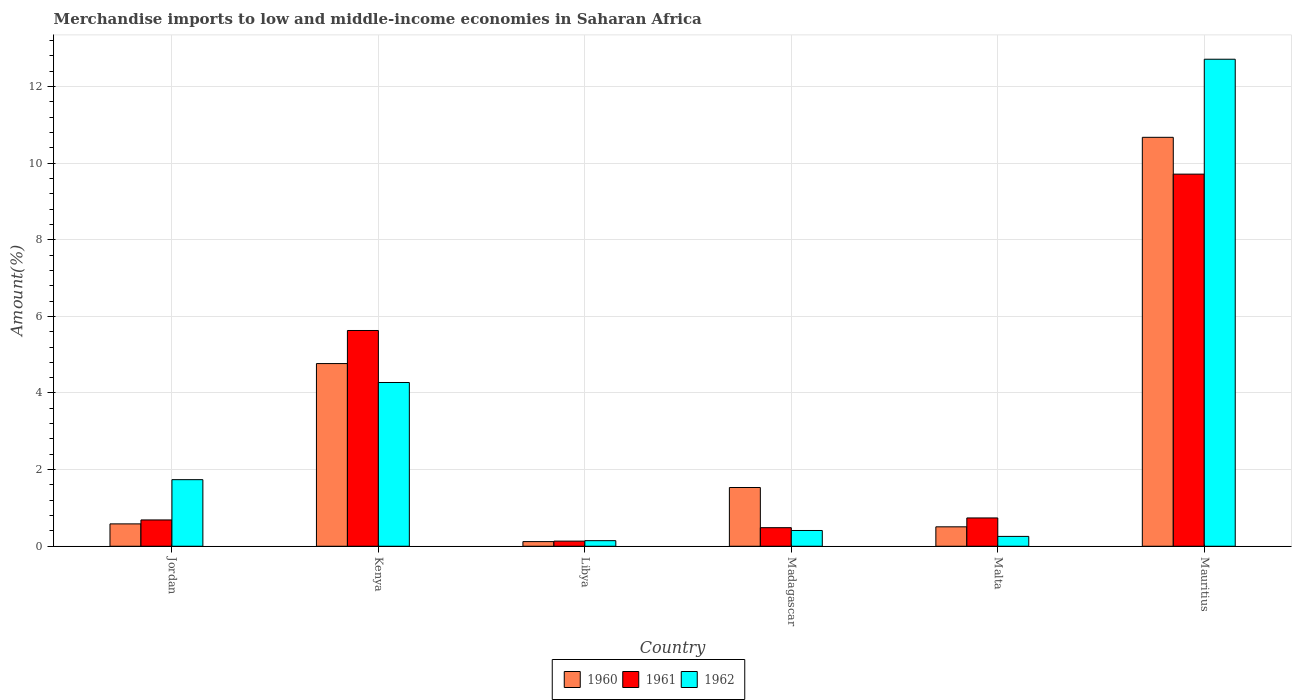Are the number of bars per tick equal to the number of legend labels?
Offer a terse response. Yes. Are the number of bars on each tick of the X-axis equal?
Offer a very short reply. Yes. How many bars are there on the 2nd tick from the left?
Ensure brevity in your answer.  3. How many bars are there on the 4th tick from the right?
Your answer should be compact. 3. What is the label of the 5th group of bars from the left?
Offer a terse response. Malta. What is the percentage of amount earned from merchandise imports in 1962 in Mauritius?
Your answer should be very brief. 12.71. Across all countries, what is the maximum percentage of amount earned from merchandise imports in 1960?
Provide a short and direct response. 10.67. Across all countries, what is the minimum percentage of amount earned from merchandise imports in 1960?
Your answer should be compact. 0.12. In which country was the percentage of amount earned from merchandise imports in 1961 maximum?
Make the answer very short. Mauritius. In which country was the percentage of amount earned from merchandise imports in 1962 minimum?
Offer a terse response. Libya. What is the total percentage of amount earned from merchandise imports in 1962 in the graph?
Keep it short and to the point. 19.54. What is the difference between the percentage of amount earned from merchandise imports in 1960 in Kenya and that in Madagascar?
Give a very brief answer. 3.23. What is the difference between the percentage of amount earned from merchandise imports in 1960 in Jordan and the percentage of amount earned from merchandise imports in 1962 in Madagascar?
Offer a very short reply. 0.17. What is the average percentage of amount earned from merchandise imports in 1961 per country?
Offer a very short reply. 2.9. What is the difference between the percentage of amount earned from merchandise imports of/in 1960 and percentage of amount earned from merchandise imports of/in 1961 in Mauritius?
Offer a terse response. 0.96. In how many countries, is the percentage of amount earned from merchandise imports in 1962 greater than 10 %?
Your answer should be very brief. 1. What is the ratio of the percentage of amount earned from merchandise imports in 1962 in Libya to that in Malta?
Provide a succinct answer. 0.57. Is the percentage of amount earned from merchandise imports in 1962 in Kenya less than that in Madagascar?
Your answer should be compact. No. Is the difference between the percentage of amount earned from merchandise imports in 1960 in Jordan and Malta greater than the difference between the percentage of amount earned from merchandise imports in 1961 in Jordan and Malta?
Your answer should be compact. Yes. What is the difference between the highest and the second highest percentage of amount earned from merchandise imports in 1962?
Your answer should be very brief. -10.97. What is the difference between the highest and the lowest percentage of amount earned from merchandise imports in 1962?
Your answer should be very brief. 12.56. What does the 1st bar from the left in Jordan represents?
Give a very brief answer. 1960. Is it the case that in every country, the sum of the percentage of amount earned from merchandise imports in 1962 and percentage of amount earned from merchandise imports in 1960 is greater than the percentage of amount earned from merchandise imports in 1961?
Your answer should be very brief. Yes. Are all the bars in the graph horizontal?
Give a very brief answer. No. What is the difference between two consecutive major ticks on the Y-axis?
Your response must be concise. 2. Does the graph contain grids?
Your answer should be very brief. Yes. Where does the legend appear in the graph?
Offer a very short reply. Bottom center. What is the title of the graph?
Give a very brief answer. Merchandise imports to low and middle-income economies in Saharan Africa. What is the label or title of the X-axis?
Keep it short and to the point. Country. What is the label or title of the Y-axis?
Your response must be concise. Amount(%). What is the Amount(%) of 1960 in Jordan?
Provide a succinct answer. 0.58. What is the Amount(%) in 1961 in Jordan?
Your answer should be compact. 0.69. What is the Amount(%) in 1962 in Jordan?
Keep it short and to the point. 1.74. What is the Amount(%) in 1960 in Kenya?
Your answer should be very brief. 4.77. What is the Amount(%) of 1961 in Kenya?
Offer a terse response. 5.63. What is the Amount(%) in 1962 in Kenya?
Offer a terse response. 4.27. What is the Amount(%) of 1960 in Libya?
Offer a terse response. 0.12. What is the Amount(%) in 1961 in Libya?
Offer a terse response. 0.13. What is the Amount(%) of 1962 in Libya?
Your answer should be very brief. 0.15. What is the Amount(%) in 1960 in Madagascar?
Keep it short and to the point. 1.53. What is the Amount(%) in 1961 in Madagascar?
Offer a very short reply. 0.48. What is the Amount(%) in 1962 in Madagascar?
Ensure brevity in your answer.  0.41. What is the Amount(%) of 1960 in Malta?
Ensure brevity in your answer.  0.51. What is the Amount(%) of 1961 in Malta?
Offer a very short reply. 0.74. What is the Amount(%) in 1962 in Malta?
Your answer should be compact. 0.26. What is the Amount(%) in 1960 in Mauritius?
Your answer should be compact. 10.67. What is the Amount(%) of 1961 in Mauritius?
Offer a terse response. 9.71. What is the Amount(%) of 1962 in Mauritius?
Provide a short and direct response. 12.71. Across all countries, what is the maximum Amount(%) of 1960?
Ensure brevity in your answer.  10.67. Across all countries, what is the maximum Amount(%) of 1961?
Your answer should be very brief. 9.71. Across all countries, what is the maximum Amount(%) in 1962?
Provide a short and direct response. 12.71. Across all countries, what is the minimum Amount(%) in 1960?
Your answer should be very brief. 0.12. Across all countries, what is the minimum Amount(%) of 1961?
Ensure brevity in your answer.  0.13. Across all countries, what is the minimum Amount(%) in 1962?
Your answer should be compact. 0.15. What is the total Amount(%) in 1960 in the graph?
Give a very brief answer. 18.18. What is the total Amount(%) of 1961 in the graph?
Give a very brief answer. 17.39. What is the total Amount(%) in 1962 in the graph?
Your response must be concise. 19.54. What is the difference between the Amount(%) of 1960 in Jordan and that in Kenya?
Provide a succinct answer. -4.18. What is the difference between the Amount(%) of 1961 in Jordan and that in Kenya?
Make the answer very short. -4.94. What is the difference between the Amount(%) in 1962 in Jordan and that in Kenya?
Give a very brief answer. -2.54. What is the difference between the Amount(%) in 1960 in Jordan and that in Libya?
Ensure brevity in your answer.  0.46. What is the difference between the Amount(%) of 1961 in Jordan and that in Libya?
Offer a terse response. 0.55. What is the difference between the Amount(%) in 1962 in Jordan and that in Libya?
Your answer should be compact. 1.59. What is the difference between the Amount(%) in 1960 in Jordan and that in Madagascar?
Provide a short and direct response. -0.95. What is the difference between the Amount(%) in 1961 in Jordan and that in Madagascar?
Your answer should be very brief. 0.2. What is the difference between the Amount(%) of 1962 in Jordan and that in Madagascar?
Give a very brief answer. 1.33. What is the difference between the Amount(%) in 1960 in Jordan and that in Malta?
Your answer should be compact. 0.08. What is the difference between the Amount(%) of 1961 in Jordan and that in Malta?
Your answer should be compact. -0.05. What is the difference between the Amount(%) in 1962 in Jordan and that in Malta?
Provide a short and direct response. 1.48. What is the difference between the Amount(%) in 1960 in Jordan and that in Mauritius?
Offer a very short reply. -10.09. What is the difference between the Amount(%) of 1961 in Jordan and that in Mauritius?
Offer a very short reply. -9.03. What is the difference between the Amount(%) of 1962 in Jordan and that in Mauritius?
Your answer should be compact. -10.97. What is the difference between the Amount(%) in 1960 in Kenya and that in Libya?
Ensure brevity in your answer.  4.65. What is the difference between the Amount(%) of 1961 in Kenya and that in Libya?
Your response must be concise. 5.5. What is the difference between the Amount(%) in 1962 in Kenya and that in Libya?
Your answer should be compact. 4.13. What is the difference between the Amount(%) in 1960 in Kenya and that in Madagascar?
Ensure brevity in your answer.  3.23. What is the difference between the Amount(%) of 1961 in Kenya and that in Madagascar?
Make the answer very short. 5.15. What is the difference between the Amount(%) of 1962 in Kenya and that in Madagascar?
Ensure brevity in your answer.  3.86. What is the difference between the Amount(%) in 1960 in Kenya and that in Malta?
Your answer should be very brief. 4.26. What is the difference between the Amount(%) in 1961 in Kenya and that in Malta?
Give a very brief answer. 4.89. What is the difference between the Amount(%) of 1962 in Kenya and that in Malta?
Offer a terse response. 4.02. What is the difference between the Amount(%) of 1960 in Kenya and that in Mauritius?
Provide a short and direct response. -5.9. What is the difference between the Amount(%) in 1961 in Kenya and that in Mauritius?
Provide a short and direct response. -4.08. What is the difference between the Amount(%) of 1962 in Kenya and that in Mauritius?
Keep it short and to the point. -8.44. What is the difference between the Amount(%) in 1960 in Libya and that in Madagascar?
Provide a short and direct response. -1.41. What is the difference between the Amount(%) in 1961 in Libya and that in Madagascar?
Offer a terse response. -0.35. What is the difference between the Amount(%) of 1962 in Libya and that in Madagascar?
Offer a very short reply. -0.27. What is the difference between the Amount(%) in 1960 in Libya and that in Malta?
Ensure brevity in your answer.  -0.39. What is the difference between the Amount(%) of 1961 in Libya and that in Malta?
Your answer should be compact. -0.6. What is the difference between the Amount(%) in 1962 in Libya and that in Malta?
Keep it short and to the point. -0.11. What is the difference between the Amount(%) in 1960 in Libya and that in Mauritius?
Your response must be concise. -10.55. What is the difference between the Amount(%) in 1961 in Libya and that in Mauritius?
Give a very brief answer. -9.58. What is the difference between the Amount(%) in 1962 in Libya and that in Mauritius?
Your response must be concise. -12.56. What is the difference between the Amount(%) of 1961 in Madagascar and that in Malta?
Your response must be concise. -0.25. What is the difference between the Amount(%) of 1962 in Madagascar and that in Malta?
Your answer should be very brief. 0.15. What is the difference between the Amount(%) in 1960 in Madagascar and that in Mauritius?
Give a very brief answer. -9.14. What is the difference between the Amount(%) in 1961 in Madagascar and that in Mauritius?
Offer a very short reply. -9.23. What is the difference between the Amount(%) of 1962 in Madagascar and that in Mauritius?
Give a very brief answer. -12.3. What is the difference between the Amount(%) in 1960 in Malta and that in Mauritius?
Your answer should be compact. -10.17. What is the difference between the Amount(%) of 1961 in Malta and that in Mauritius?
Your answer should be compact. -8.97. What is the difference between the Amount(%) in 1962 in Malta and that in Mauritius?
Give a very brief answer. -12.45. What is the difference between the Amount(%) of 1960 in Jordan and the Amount(%) of 1961 in Kenya?
Make the answer very short. -5.05. What is the difference between the Amount(%) in 1960 in Jordan and the Amount(%) in 1962 in Kenya?
Provide a succinct answer. -3.69. What is the difference between the Amount(%) of 1961 in Jordan and the Amount(%) of 1962 in Kenya?
Keep it short and to the point. -3.59. What is the difference between the Amount(%) in 1960 in Jordan and the Amount(%) in 1961 in Libya?
Your response must be concise. 0.45. What is the difference between the Amount(%) in 1960 in Jordan and the Amount(%) in 1962 in Libya?
Ensure brevity in your answer.  0.44. What is the difference between the Amount(%) of 1961 in Jordan and the Amount(%) of 1962 in Libya?
Your response must be concise. 0.54. What is the difference between the Amount(%) in 1960 in Jordan and the Amount(%) in 1961 in Madagascar?
Ensure brevity in your answer.  0.1. What is the difference between the Amount(%) in 1960 in Jordan and the Amount(%) in 1962 in Madagascar?
Keep it short and to the point. 0.17. What is the difference between the Amount(%) of 1961 in Jordan and the Amount(%) of 1962 in Madagascar?
Keep it short and to the point. 0.28. What is the difference between the Amount(%) of 1960 in Jordan and the Amount(%) of 1961 in Malta?
Ensure brevity in your answer.  -0.15. What is the difference between the Amount(%) of 1960 in Jordan and the Amount(%) of 1962 in Malta?
Offer a very short reply. 0.33. What is the difference between the Amount(%) of 1961 in Jordan and the Amount(%) of 1962 in Malta?
Offer a very short reply. 0.43. What is the difference between the Amount(%) in 1960 in Jordan and the Amount(%) in 1961 in Mauritius?
Give a very brief answer. -9.13. What is the difference between the Amount(%) in 1960 in Jordan and the Amount(%) in 1962 in Mauritius?
Give a very brief answer. -12.13. What is the difference between the Amount(%) of 1961 in Jordan and the Amount(%) of 1962 in Mauritius?
Offer a terse response. -12.02. What is the difference between the Amount(%) in 1960 in Kenya and the Amount(%) in 1961 in Libya?
Keep it short and to the point. 4.63. What is the difference between the Amount(%) of 1960 in Kenya and the Amount(%) of 1962 in Libya?
Provide a short and direct response. 4.62. What is the difference between the Amount(%) of 1961 in Kenya and the Amount(%) of 1962 in Libya?
Keep it short and to the point. 5.49. What is the difference between the Amount(%) in 1960 in Kenya and the Amount(%) in 1961 in Madagascar?
Provide a succinct answer. 4.28. What is the difference between the Amount(%) of 1960 in Kenya and the Amount(%) of 1962 in Madagascar?
Provide a succinct answer. 4.36. What is the difference between the Amount(%) in 1961 in Kenya and the Amount(%) in 1962 in Madagascar?
Make the answer very short. 5.22. What is the difference between the Amount(%) of 1960 in Kenya and the Amount(%) of 1961 in Malta?
Your response must be concise. 4.03. What is the difference between the Amount(%) of 1960 in Kenya and the Amount(%) of 1962 in Malta?
Make the answer very short. 4.51. What is the difference between the Amount(%) in 1961 in Kenya and the Amount(%) in 1962 in Malta?
Offer a terse response. 5.37. What is the difference between the Amount(%) of 1960 in Kenya and the Amount(%) of 1961 in Mauritius?
Provide a succinct answer. -4.94. What is the difference between the Amount(%) of 1960 in Kenya and the Amount(%) of 1962 in Mauritius?
Give a very brief answer. -7.94. What is the difference between the Amount(%) in 1961 in Kenya and the Amount(%) in 1962 in Mauritius?
Give a very brief answer. -7.08. What is the difference between the Amount(%) of 1960 in Libya and the Amount(%) of 1961 in Madagascar?
Ensure brevity in your answer.  -0.36. What is the difference between the Amount(%) in 1960 in Libya and the Amount(%) in 1962 in Madagascar?
Ensure brevity in your answer.  -0.29. What is the difference between the Amount(%) of 1961 in Libya and the Amount(%) of 1962 in Madagascar?
Offer a terse response. -0.28. What is the difference between the Amount(%) of 1960 in Libya and the Amount(%) of 1961 in Malta?
Your answer should be very brief. -0.62. What is the difference between the Amount(%) in 1960 in Libya and the Amount(%) in 1962 in Malta?
Your response must be concise. -0.14. What is the difference between the Amount(%) in 1961 in Libya and the Amount(%) in 1962 in Malta?
Offer a very short reply. -0.12. What is the difference between the Amount(%) in 1960 in Libya and the Amount(%) in 1961 in Mauritius?
Ensure brevity in your answer.  -9.59. What is the difference between the Amount(%) in 1960 in Libya and the Amount(%) in 1962 in Mauritius?
Ensure brevity in your answer.  -12.59. What is the difference between the Amount(%) in 1961 in Libya and the Amount(%) in 1962 in Mauritius?
Give a very brief answer. -12.58. What is the difference between the Amount(%) of 1960 in Madagascar and the Amount(%) of 1961 in Malta?
Your answer should be very brief. 0.79. What is the difference between the Amount(%) of 1960 in Madagascar and the Amount(%) of 1962 in Malta?
Keep it short and to the point. 1.28. What is the difference between the Amount(%) in 1961 in Madagascar and the Amount(%) in 1962 in Malta?
Provide a succinct answer. 0.23. What is the difference between the Amount(%) in 1960 in Madagascar and the Amount(%) in 1961 in Mauritius?
Give a very brief answer. -8.18. What is the difference between the Amount(%) of 1960 in Madagascar and the Amount(%) of 1962 in Mauritius?
Your answer should be compact. -11.18. What is the difference between the Amount(%) of 1961 in Madagascar and the Amount(%) of 1962 in Mauritius?
Ensure brevity in your answer.  -12.23. What is the difference between the Amount(%) of 1960 in Malta and the Amount(%) of 1961 in Mauritius?
Keep it short and to the point. -9.2. What is the difference between the Amount(%) of 1960 in Malta and the Amount(%) of 1962 in Mauritius?
Offer a very short reply. -12.2. What is the difference between the Amount(%) in 1961 in Malta and the Amount(%) in 1962 in Mauritius?
Offer a very short reply. -11.97. What is the average Amount(%) of 1960 per country?
Give a very brief answer. 3.03. What is the average Amount(%) of 1961 per country?
Provide a succinct answer. 2.9. What is the average Amount(%) in 1962 per country?
Offer a very short reply. 3.26. What is the difference between the Amount(%) in 1960 and Amount(%) in 1961 in Jordan?
Offer a very short reply. -0.1. What is the difference between the Amount(%) in 1960 and Amount(%) in 1962 in Jordan?
Make the answer very short. -1.15. What is the difference between the Amount(%) of 1961 and Amount(%) of 1962 in Jordan?
Make the answer very short. -1.05. What is the difference between the Amount(%) in 1960 and Amount(%) in 1961 in Kenya?
Offer a very short reply. -0.86. What is the difference between the Amount(%) of 1960 and Amount(%) of 1962 in Kenya?
Your answer should be compact. 0.49. What is the difference between the Amount(%) in 1961 and Amount(%) in 1962 in Kenya?
Ensure brevity in your answer.  1.36. What is the difference between the Amount(%) of 1960 and Amount(%) of 1961 in Libya?
Make the answer very short. -0.01. What is the difference between the Amount(%) in 1960 and Amount(%) in 1962 in Libya?
Give a very brief answer. -0.02. What is the difference between the Amount(%) of 1961 and Amount(%) of 1962 in Libya?
Keep it short and to the point. -0.01. What is the difference between the Amount(%) of 1960 and Amount(%) of 1961 in Madagascar?
Make the answer very short. 1.05. What is the difference between the Amount(%) of 1960 and Amount(%) of 1962 in Madagascar?
Your answer should be very brief. 1.12. What is the difference between the Amount(%) of 1961 and Amount(%) of 1962 in Madagascar?
Your answer should be compact. 0.07. What is the difference between the Amount(%) of 1960 and Amount(%) of 1961 in Malta?
Give a very brief answer. -0.23. What is the difference between the Amount(%) in 1960 and Amount(%) in 1962 in Malta?
Keep it short and to the point. 0.25. What is the difference between the Amount(%) in 1961 and Amount(%) in 1962 in Malta?
Give a very brief answer. 0.48. What is the difference between the Amount(%) of 1960 and Amount(%) of 1961 in Mauritius?
Keep it short and to the point. 0.96. What is the difference between the Amount(%) in 1960 and Amount(%) in 1962 in Mauritius?
Provide a succinct answer. -2.04. What is the difference between the Amount(%) in 1961 and Amount(%) in 1962 in Mauritius?
Your response must be concise. -3. What is the ratio of the Amount(%) of 1960 in Jordan to that in Kenya?
Your answer should be compact. 0.12. What is the ratio of the Amount(%) of 1961 in Jordan to that in Kenya?
Make the answer very short. 0.12. What is the ratio of the Amount(%) of 1962 in Jordan to that in Kenya?
Give a very brief answer. 0.41. What is the ratio of the Amount(%) in 1960 in Jordan to that in Libya?
Your answer should be compact. 4.82. What is the ratio of the Amount(%) of 1961 in Jordan to that in Libya?
Your response must be concise. 5.12. What is the ratio of the Amount(%) in 1962 in Jordan to that in Libya?
Make the answer very short. 11.91. What is the ratio of the Amount(%) of 1960 in Jordan to that in Madagascar?
Your answer should be very brief. 0.38. What is the ratio of the Amount(%) of 1961 in Jordan to that in Madagascar?
Offer a very short reply. 1.42. What is the ratio of the Amount(%) of 1962 in Jordan to that in Madagascar?
Provide a succinct answer. 4.23. What is the ratio of the Amount(%) of 1960 in Jordan to that in Malta?
Offer a terse response. 1.15. What is the ratio of the Amount(%) of 1961 in Jordan to that in Malta?
Make the answer very short. 0.93. What is the ratio of the Amount(%) of 1962 in Jordan to that in Malta?
Ensure brevity in your answer.  6.75. What is the ratio of the Amount(%) in 1960 in Jordan to that in Mauritius?
Keep it short and to the point. 0.05. What is the ratio of the Amount(%) of 1961 in Jordan to that in Mauritius?
Your answer should be compact. 0.07. What is the ratio of the Amount(%) in 1962 in Jordan to that in Mauritius?
Provide a succinct answer. 0.14. What is the ratio of the Amount(%) of 1960 in Kenya to that in Libya?
Offer a terse response. 39.33. What is the ratio of the Amount(%) in 1961 in Kenya to that in Libya?
Offer a terse response. 42.01. What is the ratio of the Amount(%) in 1962 in Kenya to that in Libya?
Make the answer very short. 29.29. What is the ratio of the Amount(%) in 1960 in Kenya to that in Madagascar?
Offer a terse response. 3.11. What is the ratio of the Amount(%) in 1961 in Kenya to that in Madagascar?
Give a very brief answer. 11.62. What is the ratio of the Amount(%) of 1962 in Kenya to that in Madagascar?
Your answer should be compact. 10.39. What is the ratio of the Amount(%) of 1960 in Kenya to that in Malta?
Make the answer very short. 9.41. What is the ratio of the Amount(%) of 1961 in Kenya to that in Malta?
Provide a short and direct response. 7.62. What is the ratio of the Amount(%) in 1962 in Kenya to that in Malta?
Your answer should be very brief. 16.61. What is the ratio of the Amount(%) in 1960 in Kenya to that in Mauritius?
Your answer should be compact. 0.45. What is the ratio of the Amount(%) in 1961 in Kenya to that in Mauritius?
Your response must be concise. 0.58. What is the ratio of the Amount(%) of 1962 in Kenya to that in Mauritius?
Make the answer very short. 0.34. What is the ratio of the Amount(%) in 1960 in Libya to that in Madagascar?
Your answer should be compact. 0.08. What is the ratio of the Amount(%) of 1961 in Libya to that in Madagascar?
Your answer should be very brief. 0.28. What is the ratio of the Amount(%) in 1962 in Libya to that in Madagascar?
Your answer should be compact. 0.35. What is the ratio of the Amount(%) in 1960 in Libya to that in Malta?
Offer a terse response. 0.24. What is the ratio of the Amount(%) of 1961 in Libya to that in Malta?
Ensure brevity in your answer.  0.18. What is the ratio of the Amount(%) in 1962 in Libya to that in Malta?
Provide a short and direct response. 0.57. What is the ratio of the Amount(%) in 1960 in Libya to that in Mauritius?
Your answer should be compact. 0.01. What is the ratio of the Amount(%) of 1961 in Libya to that in Mauritius?
Ensure brevity in your answer.  0.01. What is the ratio of the Amount(%) of 1962 in Libya to that in Mauritius?
Offer a terse response. 0.01. What is the ratio of the Amount(%) in 1960 in Madagascar to that in Malta?
Provide a succinct answer. 3.02. What is the ratio of the Amount(%) of 1961 in Madagascar to that in Malta?
Ensure brevity in your answer.  0.66. What is the ratio of the Amount(%) in 1962 in Madagascar to that in Malta?
Keep it short and to the point. 1.6. What is the ratio of the Amount(%) in 1960 in Madagascar to that in Mauritius?
Ensure brevity in your answer.  0.14. What is the ratio of the Amount(%) of 1961 in Madagascar to that in Mauritius?
Ensure brevity in your answer.  0.05. What is the ratio of the Amount(%) of 1962 in Madagascar to that in Mauritius?
Offer a very short reply. 0.03. What is the ratio of the Amount(%) in 1960 in Malta to that in Mauritius?
Your response must be concise. 0.05. What is the ratio of the Amount(%) in 1961 in Malta to that in Mauritius?
Make the answer very short. 0.08. What is the ratio of the Amount(%) in 1962 in Malta to that in Mauritius?
Provide a short and direct response. 0.02. What is the difference between the highest and the second highest Amount(%) of 1960?
Your answer should be very brief. 5.9. What is the difference between the highest and the second highest Amount(%) of 1961?
Give a very brief answer. 4.08. What is the difference between the highest and the second highest Amount(%) in 1962?
Ensure brevity in your answer.  8.44. What is the difference between the highest and the lowest Amount(%) of 1960?
Ensure brevity in your answer.  10.55. What is the difference between the highest and the lowest Amount(%) in 1961?
Offer a very short reply. 9.58. What is the difference between the highest and the lowest Amount(%) of 1962?
Ensure brevity in your answer.  12.56. 